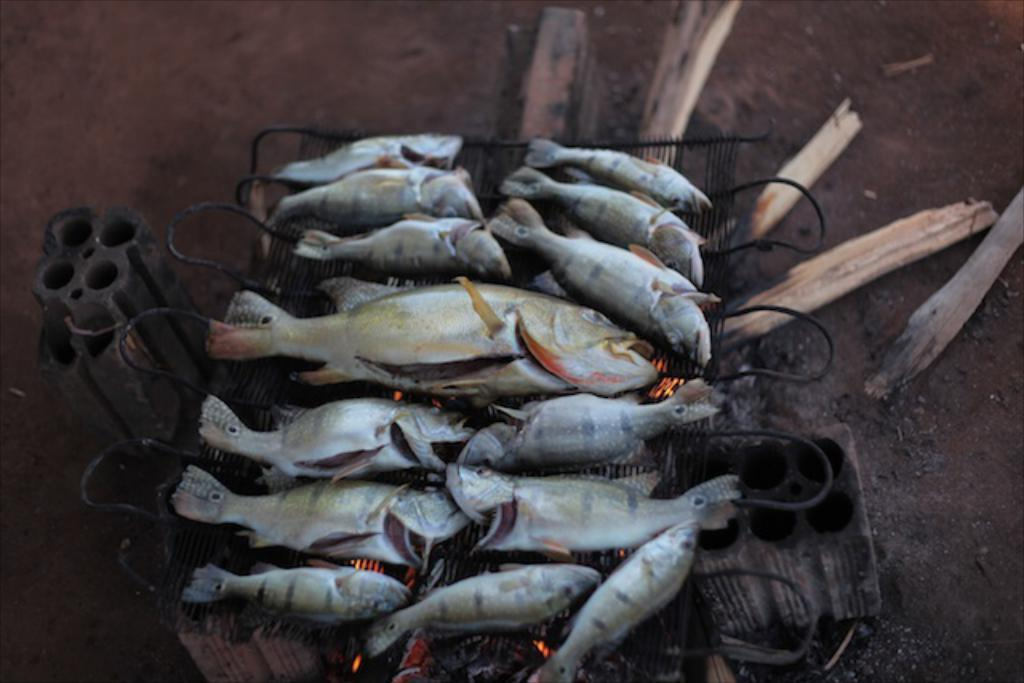What is being cooked on the grill in the image? There are fishes on a grill in the image. What type of material is used for the objects in the image? There are wooden objects in the image. Can you describe the other unspecified objects in the image? Unfortunately, the facts provided do not specify the nature of the other unspecified objects in the image. What type of humor is being displayed by the trees in the image? There are no trees present in the image, so it is not possible to determine if any humor is being displayed by them. 